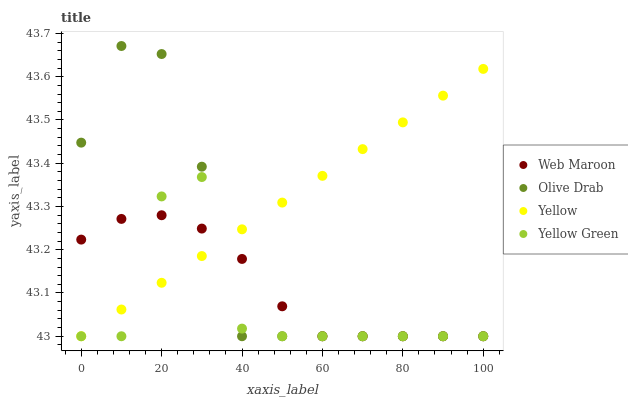Does Yellow Green have the minimum area under the curve?
Answer yes or no. Yes. Does Yellow have the maximum area under the curve?
Answer yes or no. Yes. Does Olive Drab have the minimum area under the curve?
Answer yes or no. No. Does Olive Drab have the maximum area under the curve?
Answer yes or no. No. Is Yellow the smoothest?
Answer yes or no. Yes. Is Yellow Green the roughest?
Answer yes or no. Yes. Is Olive Drab the smoothest?
Answer yes or no. No. Is Olive Drab the roughest?
Answer yes or no. No. Does Web Maroon have the lowest value?
Answer yes or no. Yes. Does Olive Drab have the highest value?
Answer yes or no. Yes. Does Yellow have the highest value?
Answer yes or no. No. Does Yellow intersect Web Maroon?
Answer yes or no. Yes. Is Yellow less than Web Maroon?
Answer yes or no. No. Is Yellow greater than Web Maroon?
Answer yes or no. No. 